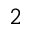Convert formula to latex. <formula><loc_0><loc_0><loc_500><loc_500>^ { 2 }</formula> 